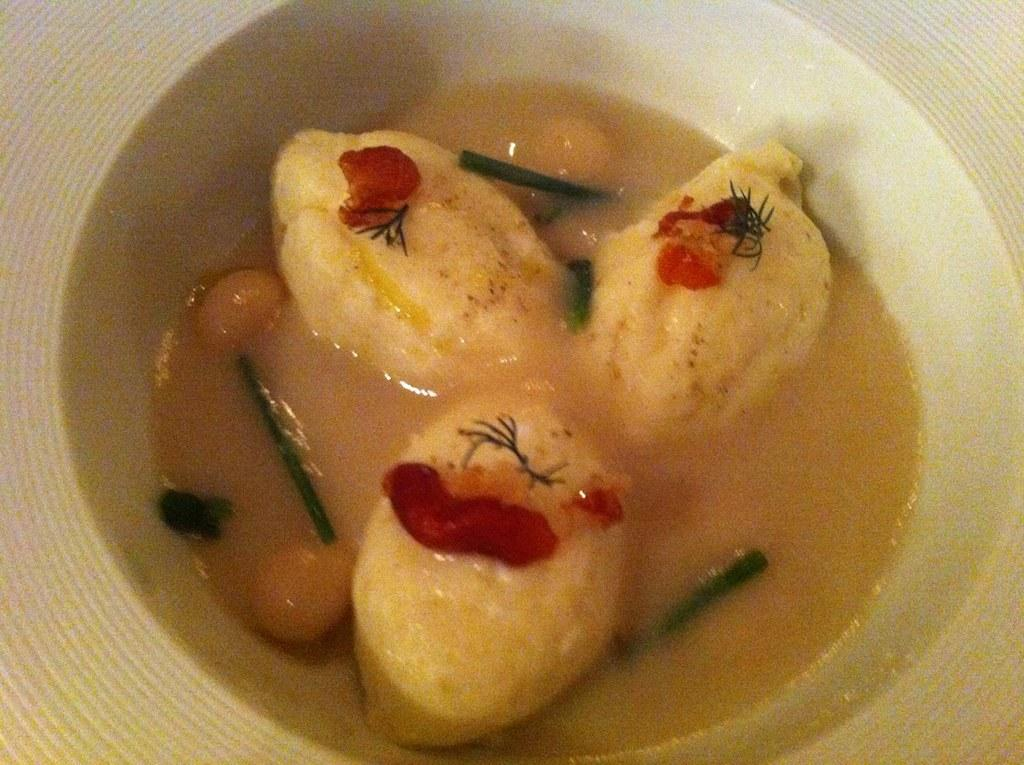What object is present in the image? There is a bowl in the image. What is inside the bowl? There is food placed in the bowl. What type of bean can be seen growing in the image? There is no bean or bean plant present in the image. 